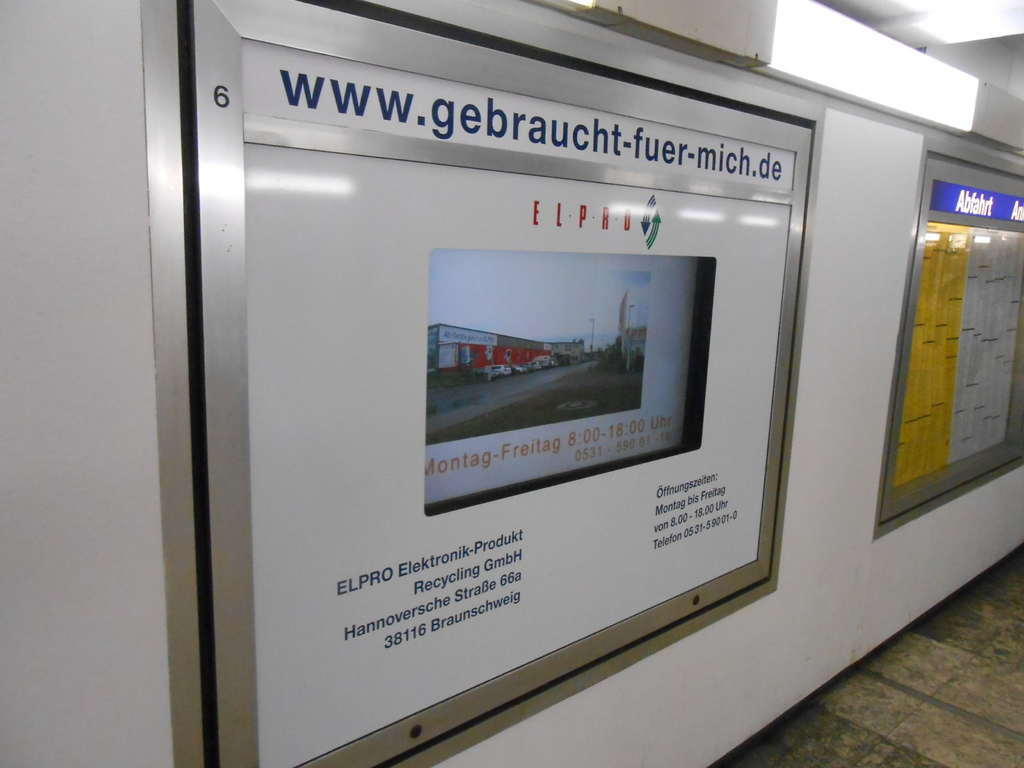Can you tell more about what 'Elektronik-Produkt Recycling' involves? Elektronik-Produkt Recycling involves processing used electronic products to reclaim valuable materials or safely dispose of hazardous components. This includes dismantling devices, sorting parts, and extracting materials like metals and plastics for reuse, thereby reducing electronic waste and its environmental impact. 